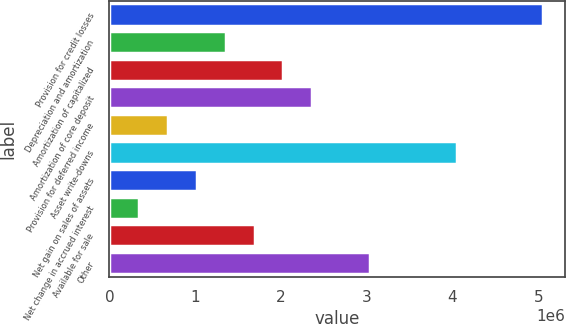Convert chart. <chart><loc_0><loc_0><loc_500><loc_500><bar_chart><fcel>Provision for credit losses<fcel>Depreciation and amortization<fcel>Amortization of capitalized<fcel>Amortization of core deposit<fcel>Provision for deferred income<fcel>Asset write-downs<fcel>Net gain on sales of assets<fcel>Net change in accrued interest<fcel>Available for sale<fcel>Other<nl><fcel>5.05726e+06<fcel>1.35458e+06<fcel>2.02779e+06<fcel>2.3644e+06<fcel>681361<fcel>4.04743e+06<fcel>1.01797e+06<fcel>344754<fcel>1.69118e+06<fcel>3.03761e+06<nl></chart> 